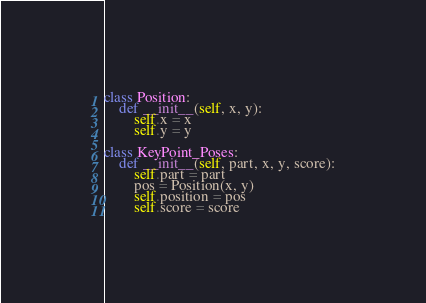Convert code to text. <code><loc_0><loc_0><loc_500><loc_500><_Python_>class Position:
    def __init__(self, x, y):
        self.x = x
        self.y = y

class KeyPoint_Poses:
    def __init__(self, part, x, y, score):
        self.part = part
        pos = Position(x, y)
        self.position = pos
        self.score = score</code> 